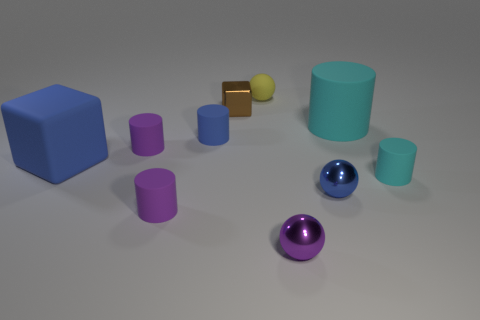What is the color of the small shiny object that is behind the large block?
Keep it short and to the point. Brown. There is a tiny object that is on the right side of the blue object in front of the large rubber cube; what number of matte cylinders are on the right side of it?
Provide a short and direct response. 0. The yellow thing is what size?
Offer a terse response. Small. There is a blue sphere that is the same size as the yellow matte object; what material is it?
Your answer should be compact. Metal. There is a tiny blue shiny sphere; what number of small things are on the left side of it?
Your answer should be very brief. 6. Are the purple cylinder behind the big cube and the small purple object on the right side of the tiny shiny block made of the same material?
Provide a succinct answer. No. What shape is the rubber object in front of the small rubber thing that is right of the small sphere behind the big cyan rubber object?
Your answer should be compact. Cylinder. What is the shape of the brown object?
Provide a short and direct response. Cube. The cyan matte thing that is the same size as the blue rubber block is what shape?
Provide a succinct answer. Cylinder. What number of other objects are there of the same color as the tiny cube?
Your answer should be very brief. 0. 